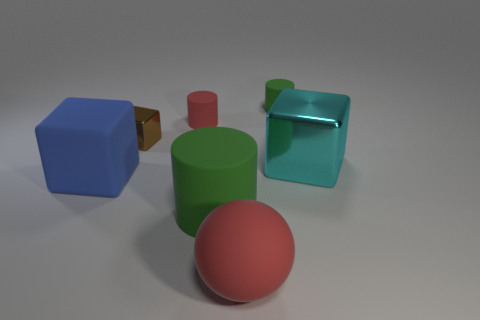Subtract all small red rubber cylinders. How many cylinders are left? 2 Subtract all red cylinders. How many cylinders are left? 2 Subtract 1 blocks. How many blocks are left? 2 Add 3 cyan things. How many objects exist? 10 Subtract all red cubes. How many green cylinders are left? 2 Subtract all balls. How many objects are left? 6 Add 7 large cyan things. How many large cyan things exist? 8 Subtract 0 red blocks. How many objects are left? 7 Subtract all yellow spheres. Subtract all red cylinders. How many spheres are left? 1 Subtract all red rubber objects. Subtract all purple rubber blocks. How many objects are left? 5 